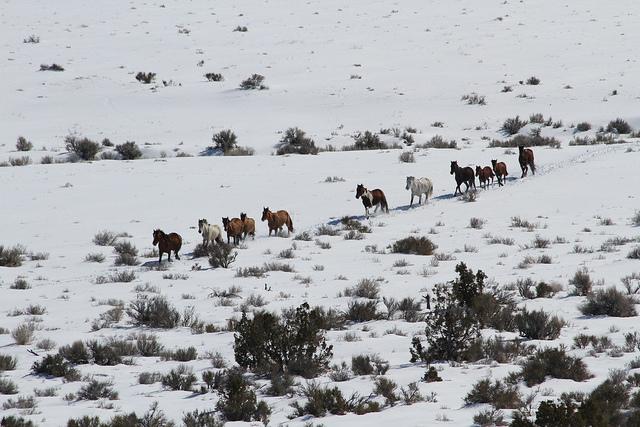Are these horses crossing a river?
Short answer required. No. What color is the animal leading the group?
Answer briefly. Brown. Are these sailing boats?
Be succinct. No. What kinds of animals are these?
Short answer required. Horses. Is there water in the photo?
Keep it brief. No. 